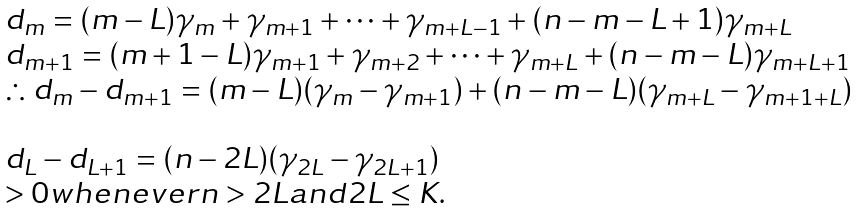<formula> <loc_0><loc_0><loc_500><loc_500>\begin{array} { l } d _ { m } = ( m - L ) \gamma _ { m } + \gamma _ { m + 1 } + \dots + \gamma _ { m + L - 1 } + ( n - m - L + 1 ) \gamma _ { m + L } \\ d _ { m + 1 } = ( m + 1 - L ) \gamma _ { m + 1 } + \gamma _ { m + 2 } + \dots + \gamma _ { m + L } + ( n - m - L ) \gamma _ { m + L + 1 } \\ \therefore d _ { m } - d _ { m + 1 } = ( m - L ) ( \gamma _ { m } - \gamma _ { m + 1 } ) + ( n - m - L ) ( \gamma _ { m + L } - \gamma _ { m + 1 + L } ) \\ \\ d _ { L } - d _ { L + 1 } = ( n - 2 L ) ( \gamma _ { 2 L } - \gamma _ { 2 L + 1 } ) \\ > 0 w h e n e v e r n > 2 L a n d 2 L \leq K . \end{array}</formula> 